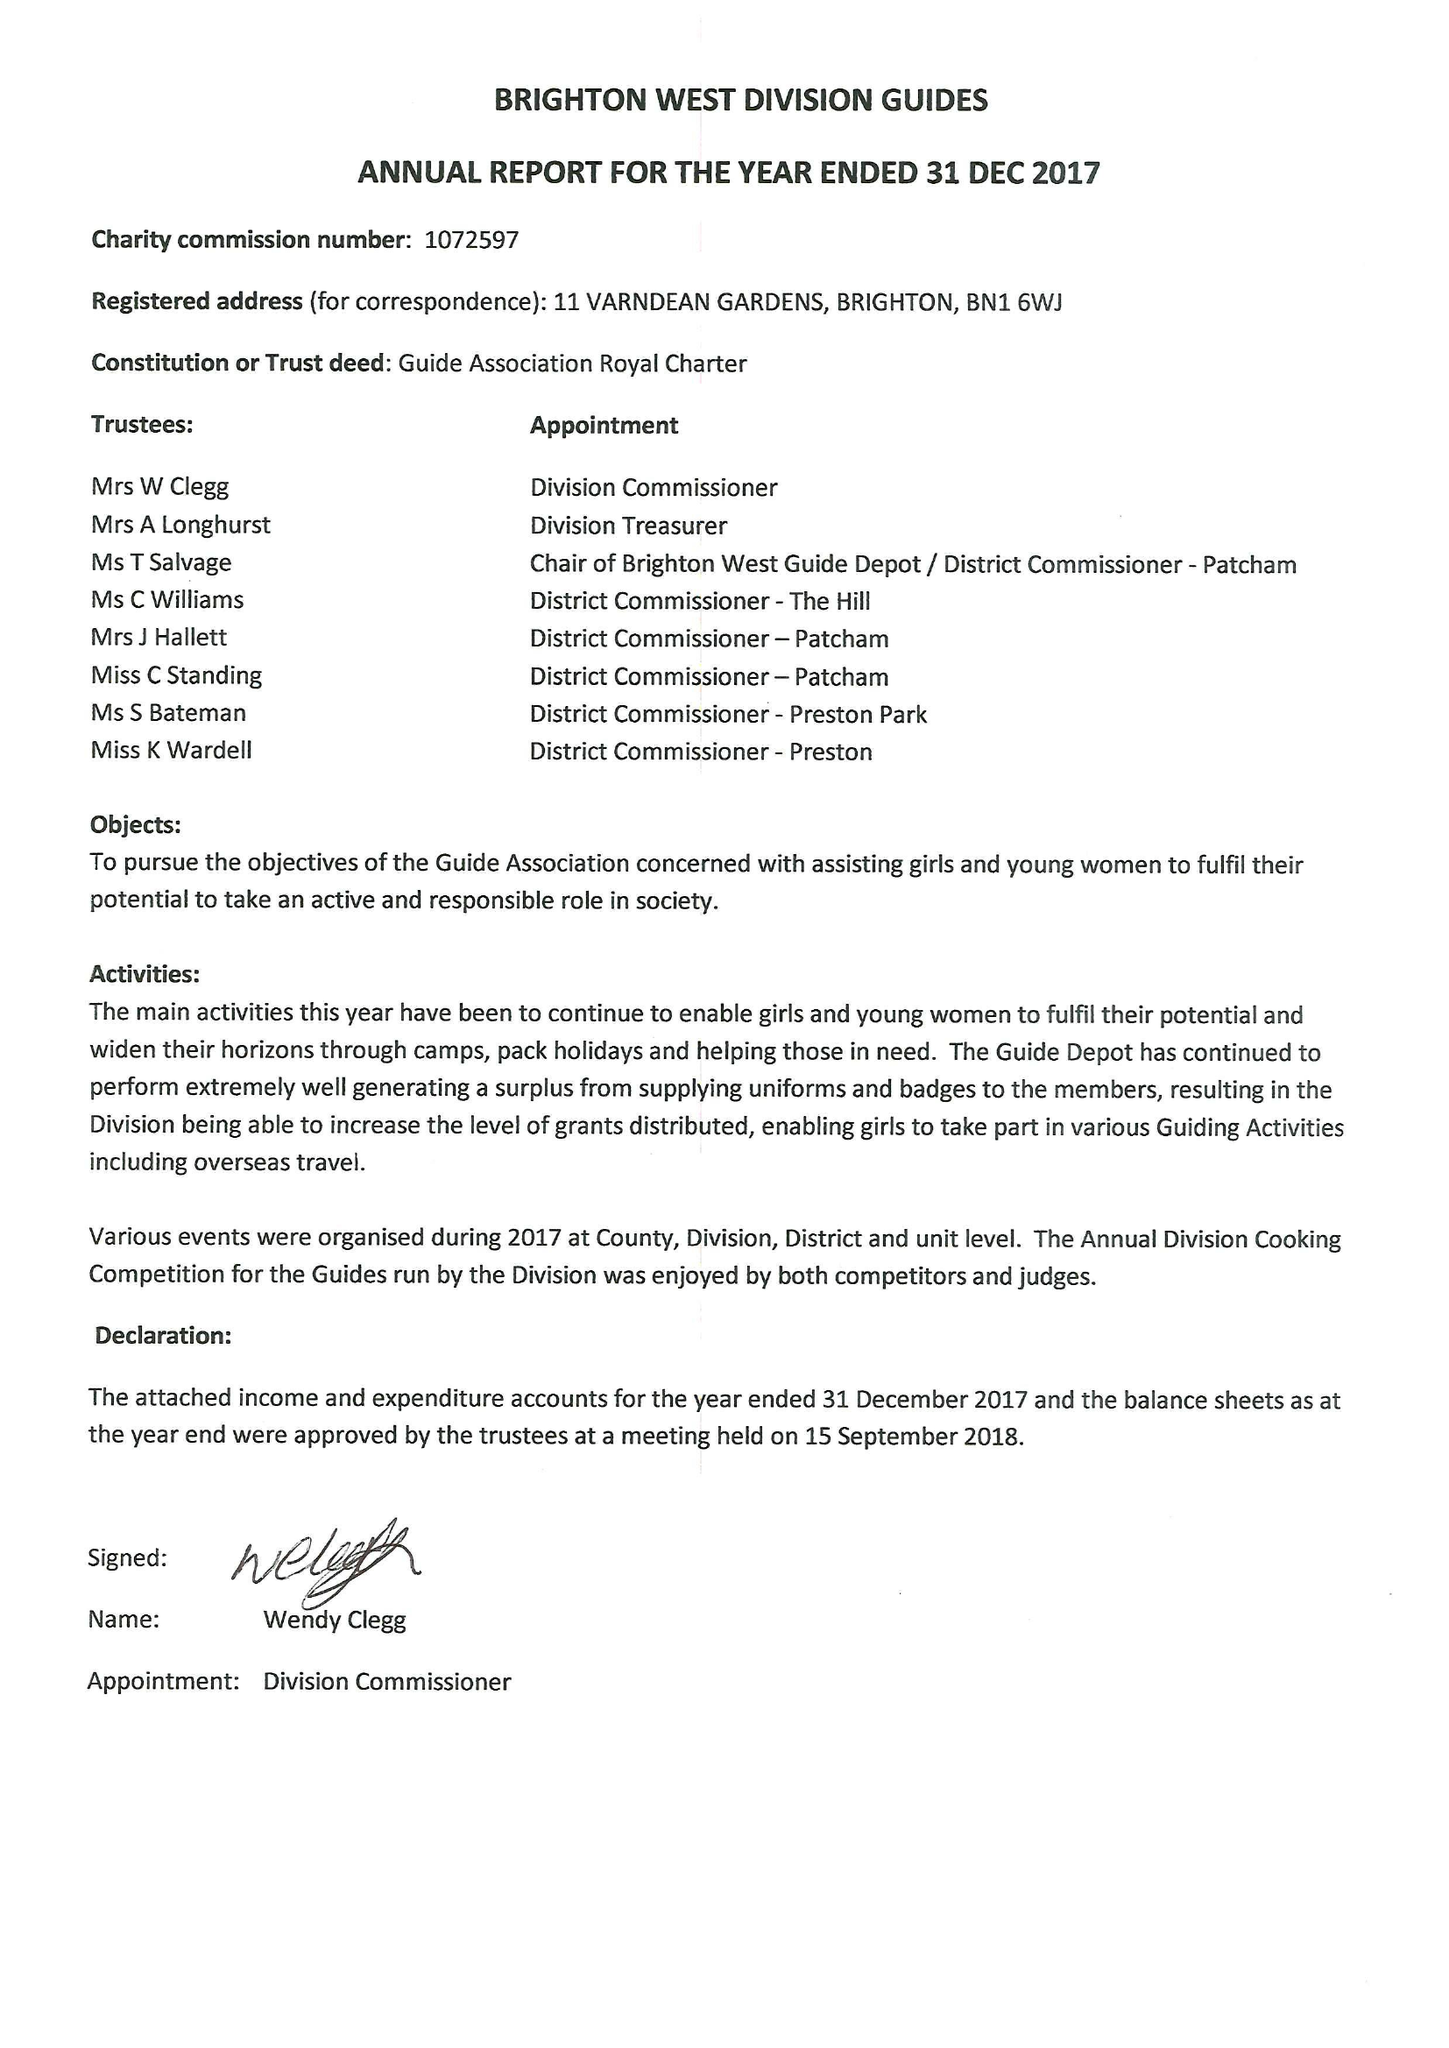What is the value for the income_annually_in_british_pounds?
Answer the question using a single word or phrase. 38833.00 